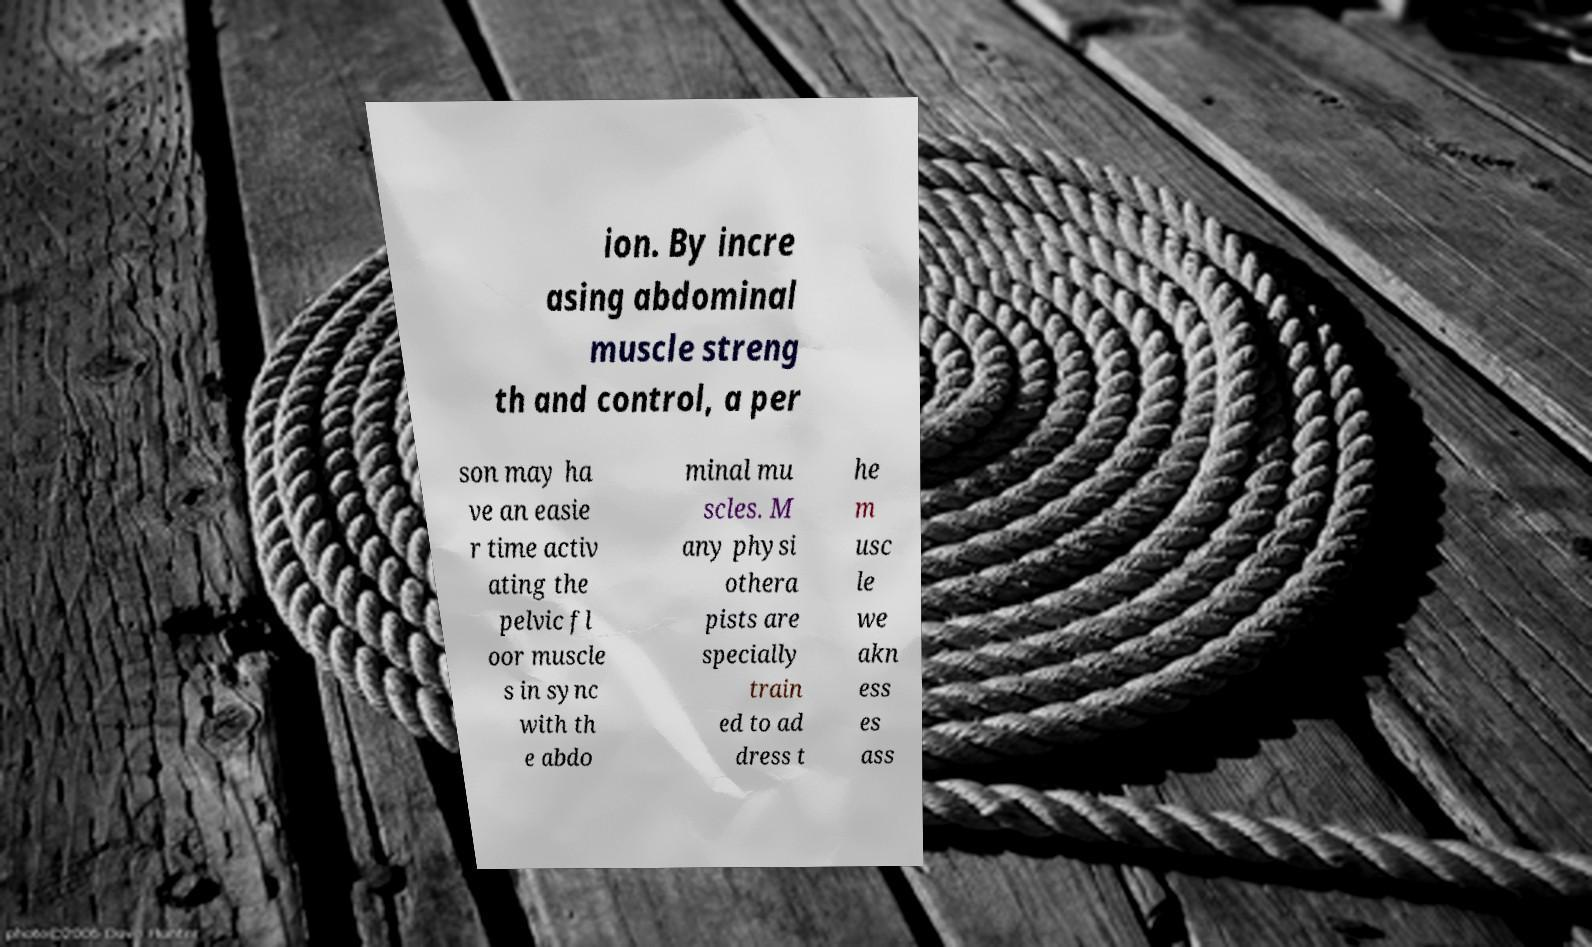Can you accurately transcribe the text from the provided image for me? ion. By incre asing abdominal muscle streng th and control, a per son may ha ve an easie r time activ ating the pelvic fl oor muscle s in sync with th e abdo minal mu scles. M any physi othera pists are specially train ed to ad dress t he m usc le we akn ess es ass 